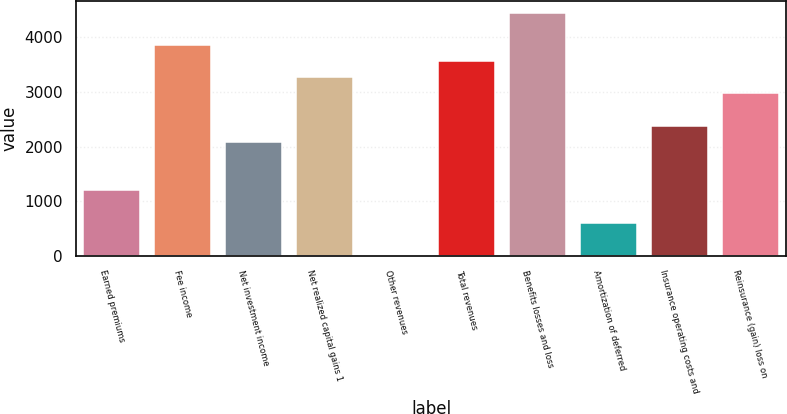Convert chart. <chart><loc_0><loc_0><loc_500><loc_500><bar_chart><fcel>Earned premiums<fcel>Fee income<fcel>Net investment income<fcel>Net realized capital gains 1<fcel>Other revenues<fcel>Total revenues<fcel>Benefits losses and loss<fcel>Amortization of deferred<fcel>Insurance operating costs and<fcel>Reinsurance (gain) loss on<nl><fcel>1199.4<fcel>3859.8<fcel>2086.2<fcel>3268.6<fcel>17<fcel>3564.2<fcel>4451<fcel>608.2<fcel>2381.8<fcel>2973<nl></chart> 